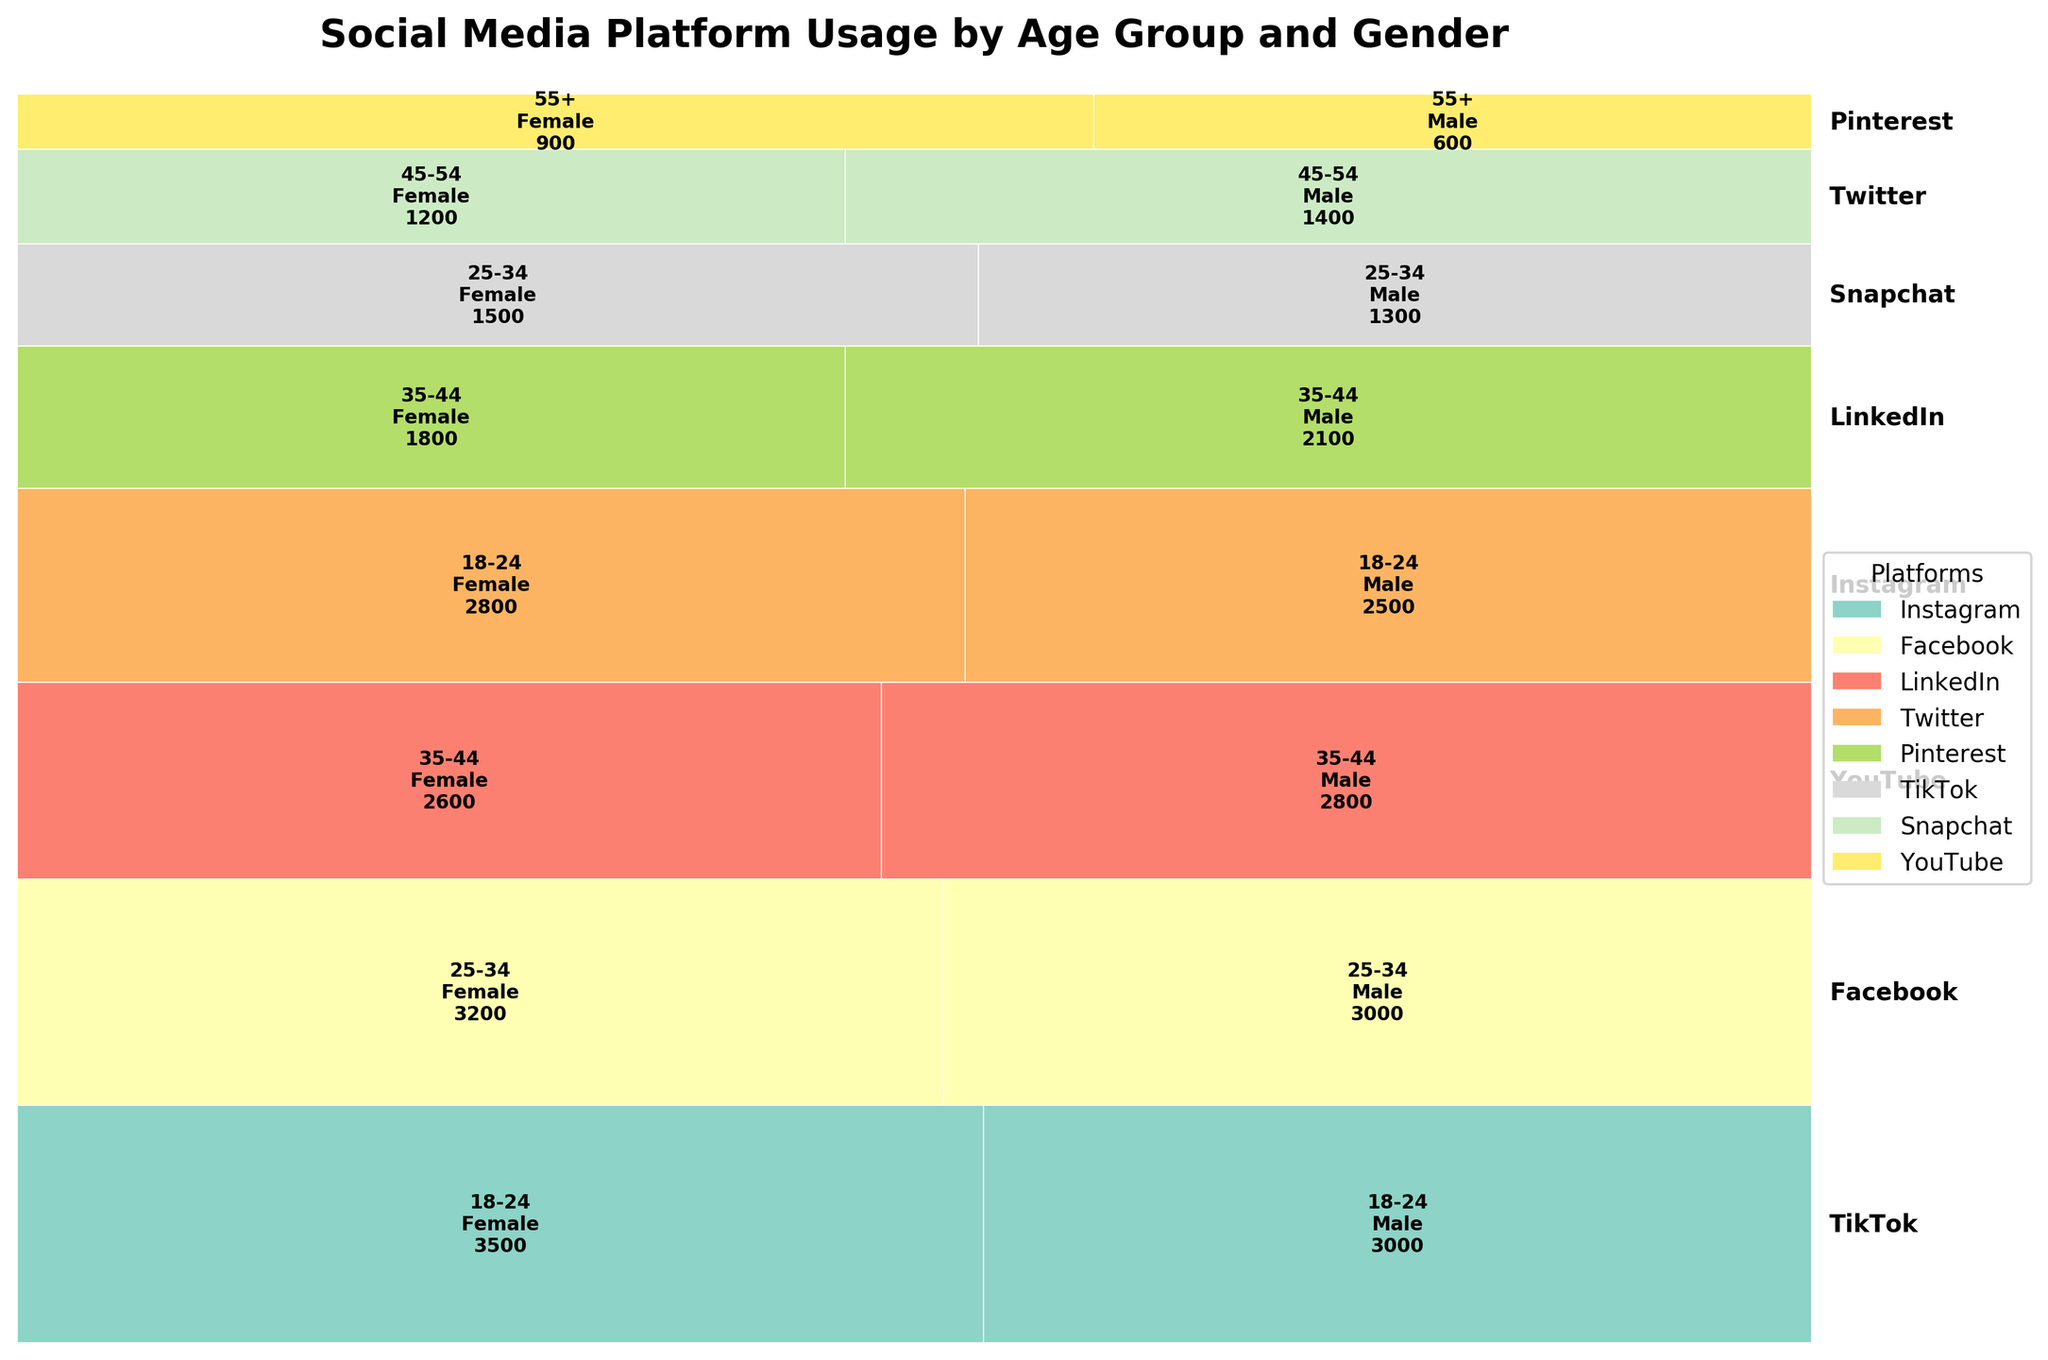Which social media platform has the highest usage among 18-24 age group females? Look at the segment corresponding to 18-24 age group females and check which platform has the largest area.
Answer: TikTok Which gender uses Pinterest more in the 55+ age group? Examine the sections for the 55+ age group and compare the height or area of the male and female segments within Pinterest.
Answer: Female What is the combined user count of Twitter among the 45-54 age group? Sum up the user counts for both male and female users in the 45-54 age group for Twitter. The numbers from both segments would be 1200 (female) and 1400 (male).
Answer: 2600 Which age group has the most varied usage across different social media platforms? Observe the width variation within each age group across different platforms. The age group with the segments showing more variety in width (indicating varied percentage user distribution) is the most varied.
Answer: 18-24 How does Instagram usage compare between 18-24 year old males and females? Look at the segments for Instagram and compare the width or area of the male and female sections in the 18-24 age group. The section for females is slightly larger than that for males.
Answer: Females use Instagram more Which platform has more male users in the 35-44 age group, LinkedIn or YouTube? Check the respective sections for LinkedIn and YouTube in the 35-44 age group and compare the sizes of the male segments.
Answer: YouTube Which social media platform has the smallest total user base? Identify the platform with the thinnest overall vertical height in the mosaic plot.
Answer: Pinterest Which gender in the 25-34 age group uses Facebook more? Compare the sections for male and female users in the 25-34 age group for Facebook.
Answer: Female What is the social media platform predominantly used by males in the 18-24 age group? Look for the platform where the segment for males in the 18-24 age group is prominent.
Answer: TikTok Is LinkedIn more popular among males or females in the 35-44 age group? Compare the sections for males and females in the 35-44 age group for LinkedIn. The section for males is larger.
Answer: Males 